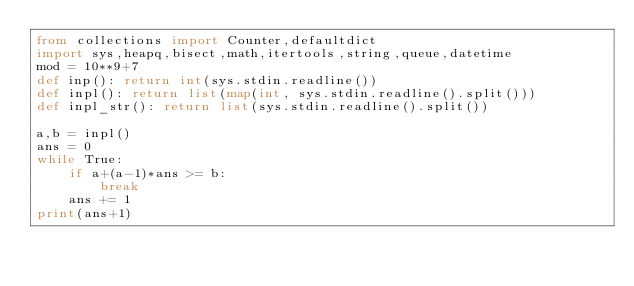<code> <loc_0><loc_0><loc_500><loc_500><_Python_>from collections import Counter,defaultdict
import sys,heapq,bisect,math,itertools,string,queue,datetime
mod = 10**9+7
def inp(): return int(sys.stdin.readline())
def inpl(): return list(map(int, sys.stdin.readline().split()))
def inpl_str(): return list(sys.stdin.readline().split())

a,b = inpl()
ans = 0
while True:
    if a+(a-1)*ans >= b:
        break
    ans += 1
print(ans+1)</code> 